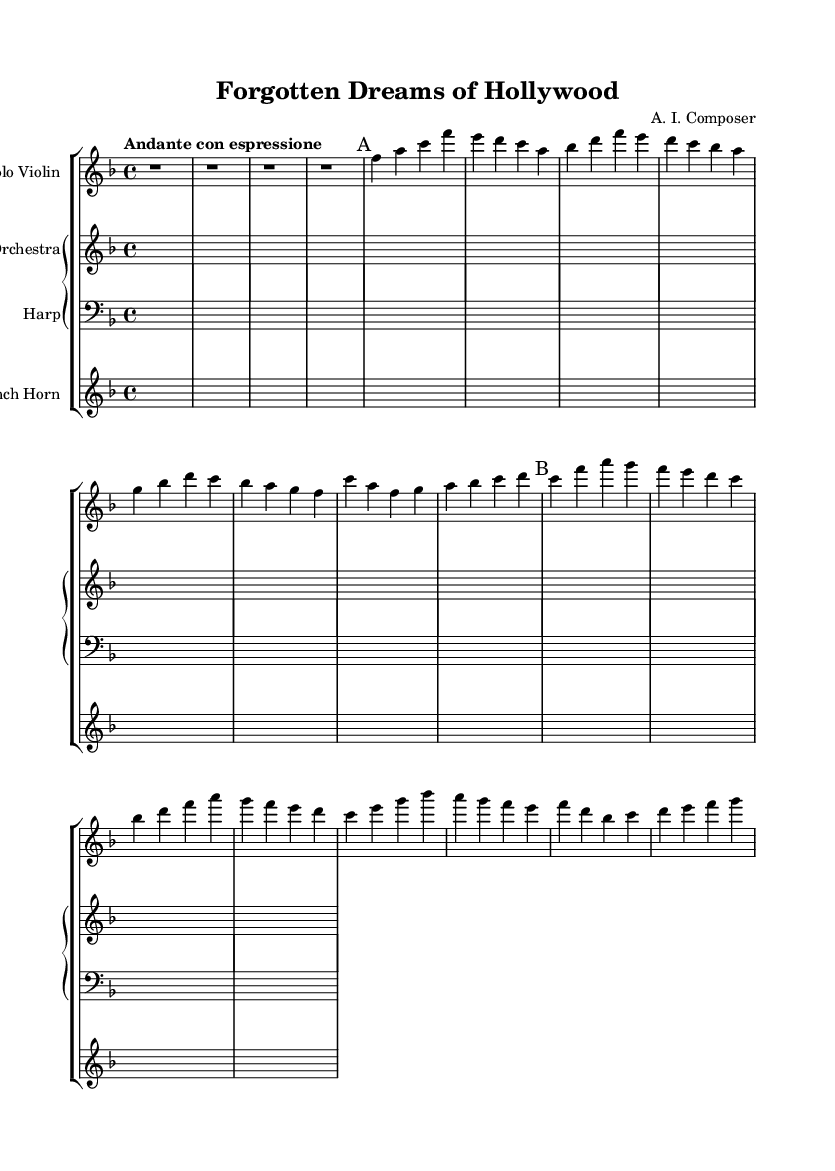What is the key signature of this music? The key signature is F major, which has one flat (B flat). This can be determined by looking at the key signature shown in the beginning of the score.
Answer: F major What is the time signature of this music? The time signature is 4/4, which indicates there are four beats in a measure. This is located at the beginning of the score, right after the key signature.
Answer: 4/4 What is the tempo marking for this piece? The tempo marking is "Andante con espressione," indicating a slow, expressive pace. This marking is found in the tempo section at the start of the score.
Answer: Andante con espressione How many themes are present in the music? There are two themes identified as Theme A and Theme B. These are marked explicitly in the score where the music changes from one thematic material to another.
Answer: 2 Which instrument plays the solo line? The solo line is played by the Solo Violin, as indicated at the start of the violin part. The instrumentation is specified in the staff label.
Answer: Solo Violin What is the instrument transposition for the French Horn? The French Horn is transposed in F, indicating that a written C sounds as a F when played. This transposition is noted in the staff label for the French Horn.
Answer: F 